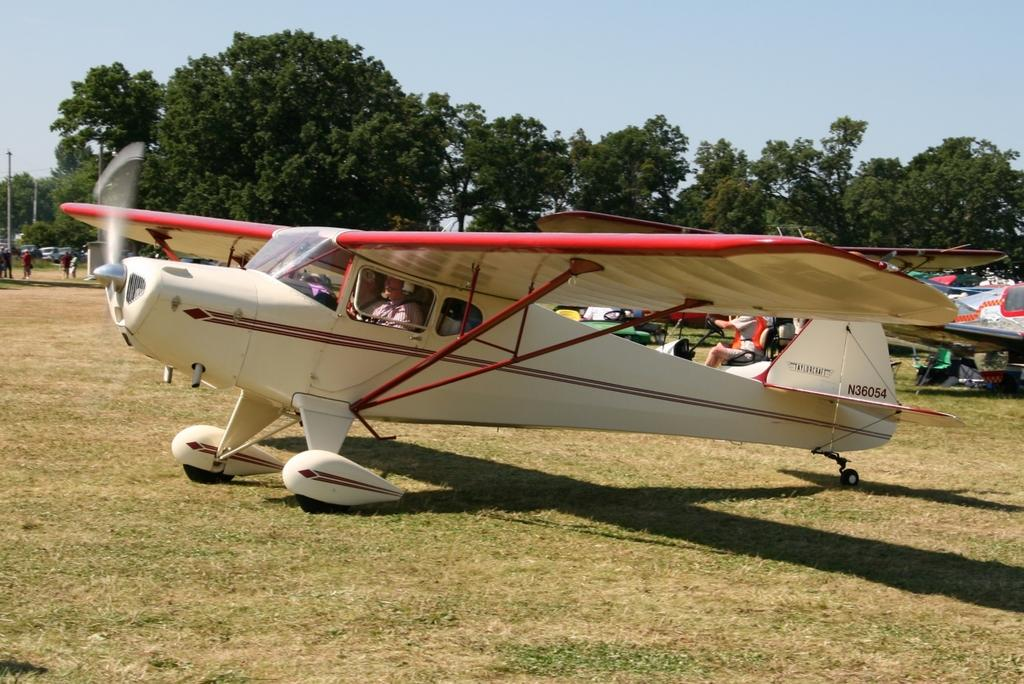What is the main subject of the image? The main subject of the image is an aircraft. Can you describe the person inside the aircraft? A person is sitting inside the aircraft. What is the ground surface like in the image? There is grass on the ground. What can be seen in the background of the image? There are many people, trees, and the sky visible in the background. Where is the wall located in the image? There is no wall present in the image. What type of camp can be seen in the background? There is no camp present in the image. 